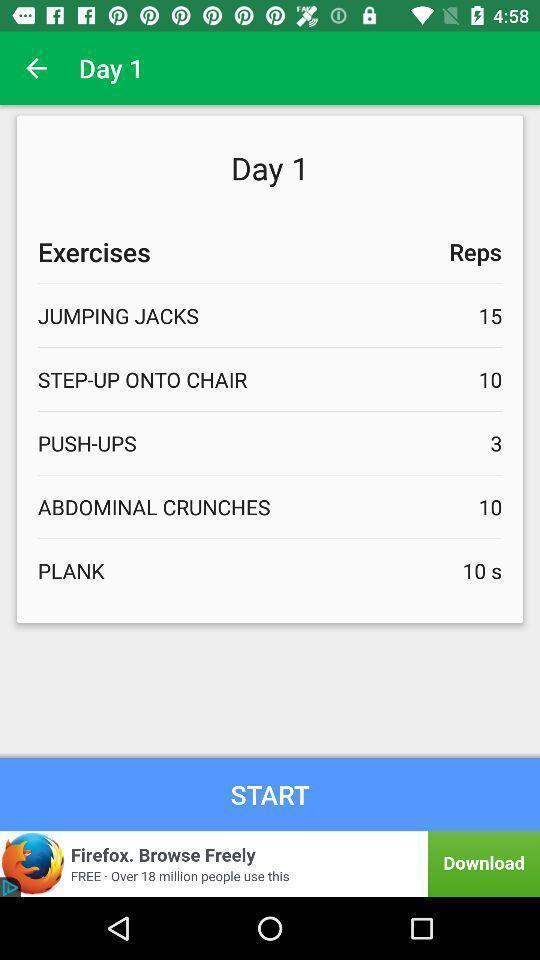Provide a description of this screenshot. Start page. 